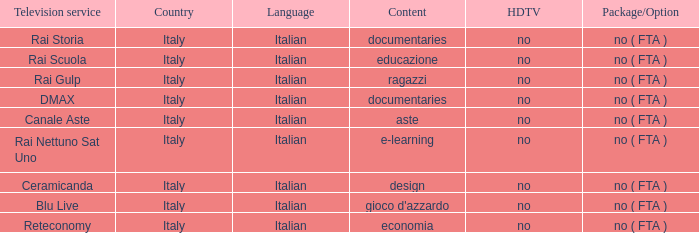What is the Country with Reteconomy as the Television service? Italy. 